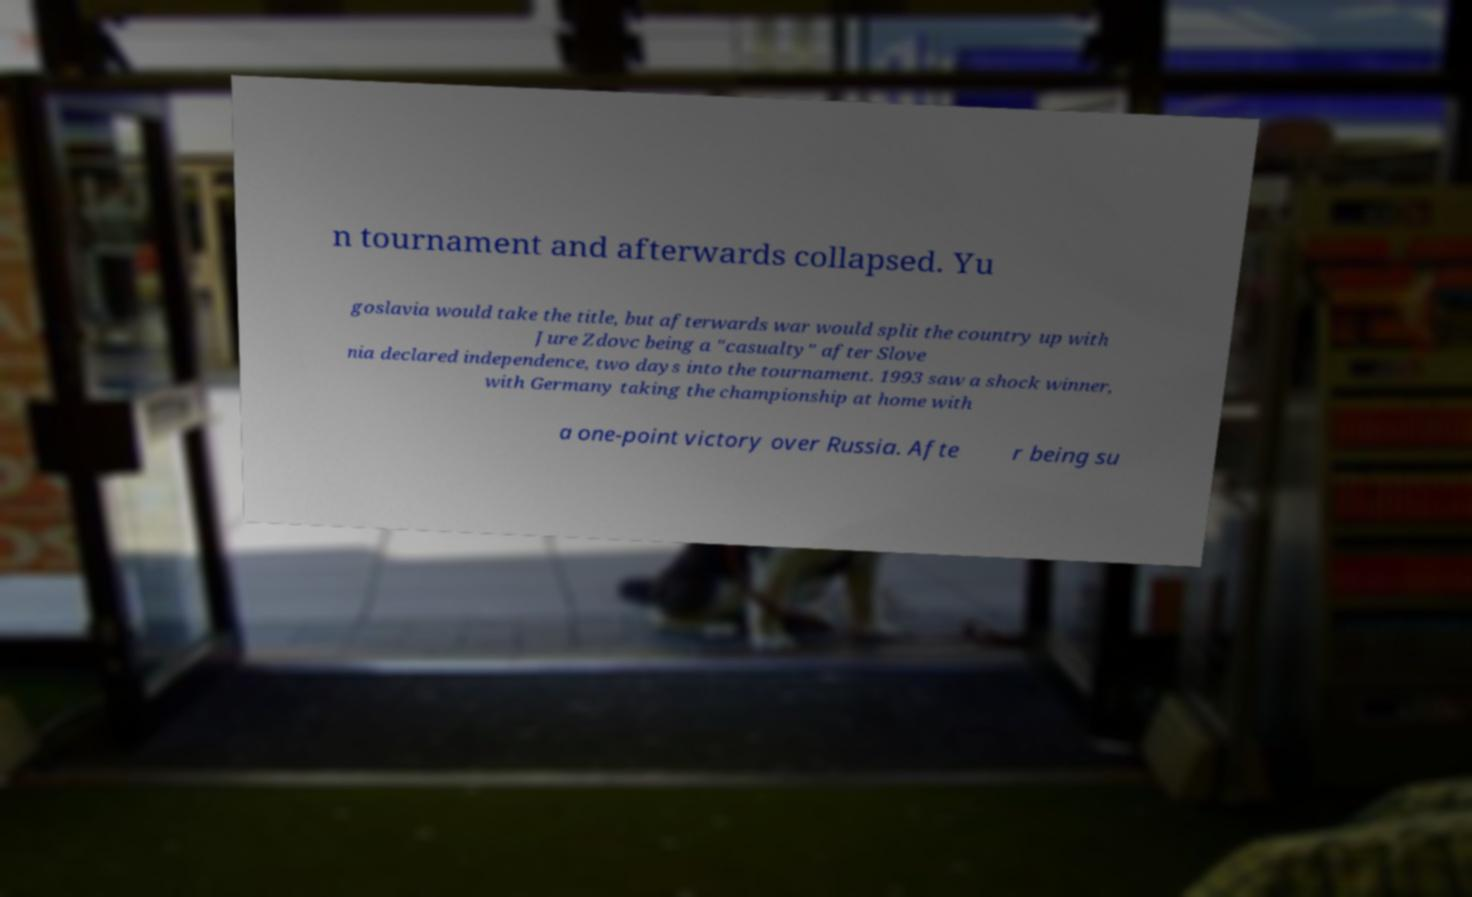Please identify and transcribe the text found in this image. n tournament and afterwards collapsed. Yu goslavia would take the title, but afterwards war would split the country up with Jure Zdovc being a "casualty" after Slove nia declared independence, two days into the tournament. 1993 saw a shock winner, with Germany taking the championship at home with a one-point victory over Russia. Afte r being su 